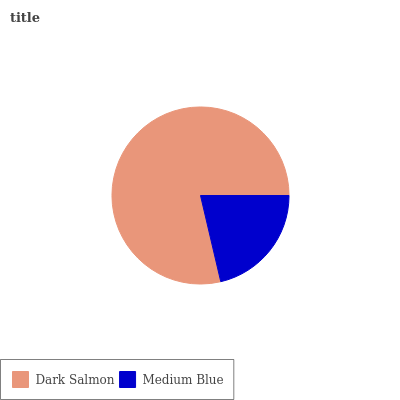Is Medium Blue the minimum?
Answer yes or no. Yes. Is Dark Salmon the maximum?
Answer yes or no. Yes. Is Medium Blue the maximum?
Answer yes or no. No. Is Dark Salmon greater than Medium Blue?
Answer yes or no. Yes. Is Medium Blue less than Dark Salmon?
Answer yes or no. Yes. Is Medium Blue greater than Dark Salmon?
Answer yes or no. No. Is Dark Salmon less than Medium Blue?
Answer yes or no. No. Is Dark Salmon the high median?
Answer yes or no. Yes. Is Medium Blue the low median?
Answer yes or no. Yes. Is Medium Blue the high median?
Answer yes or no. No. Is Dark Salmon the low median?
Answer yes or no. No. 